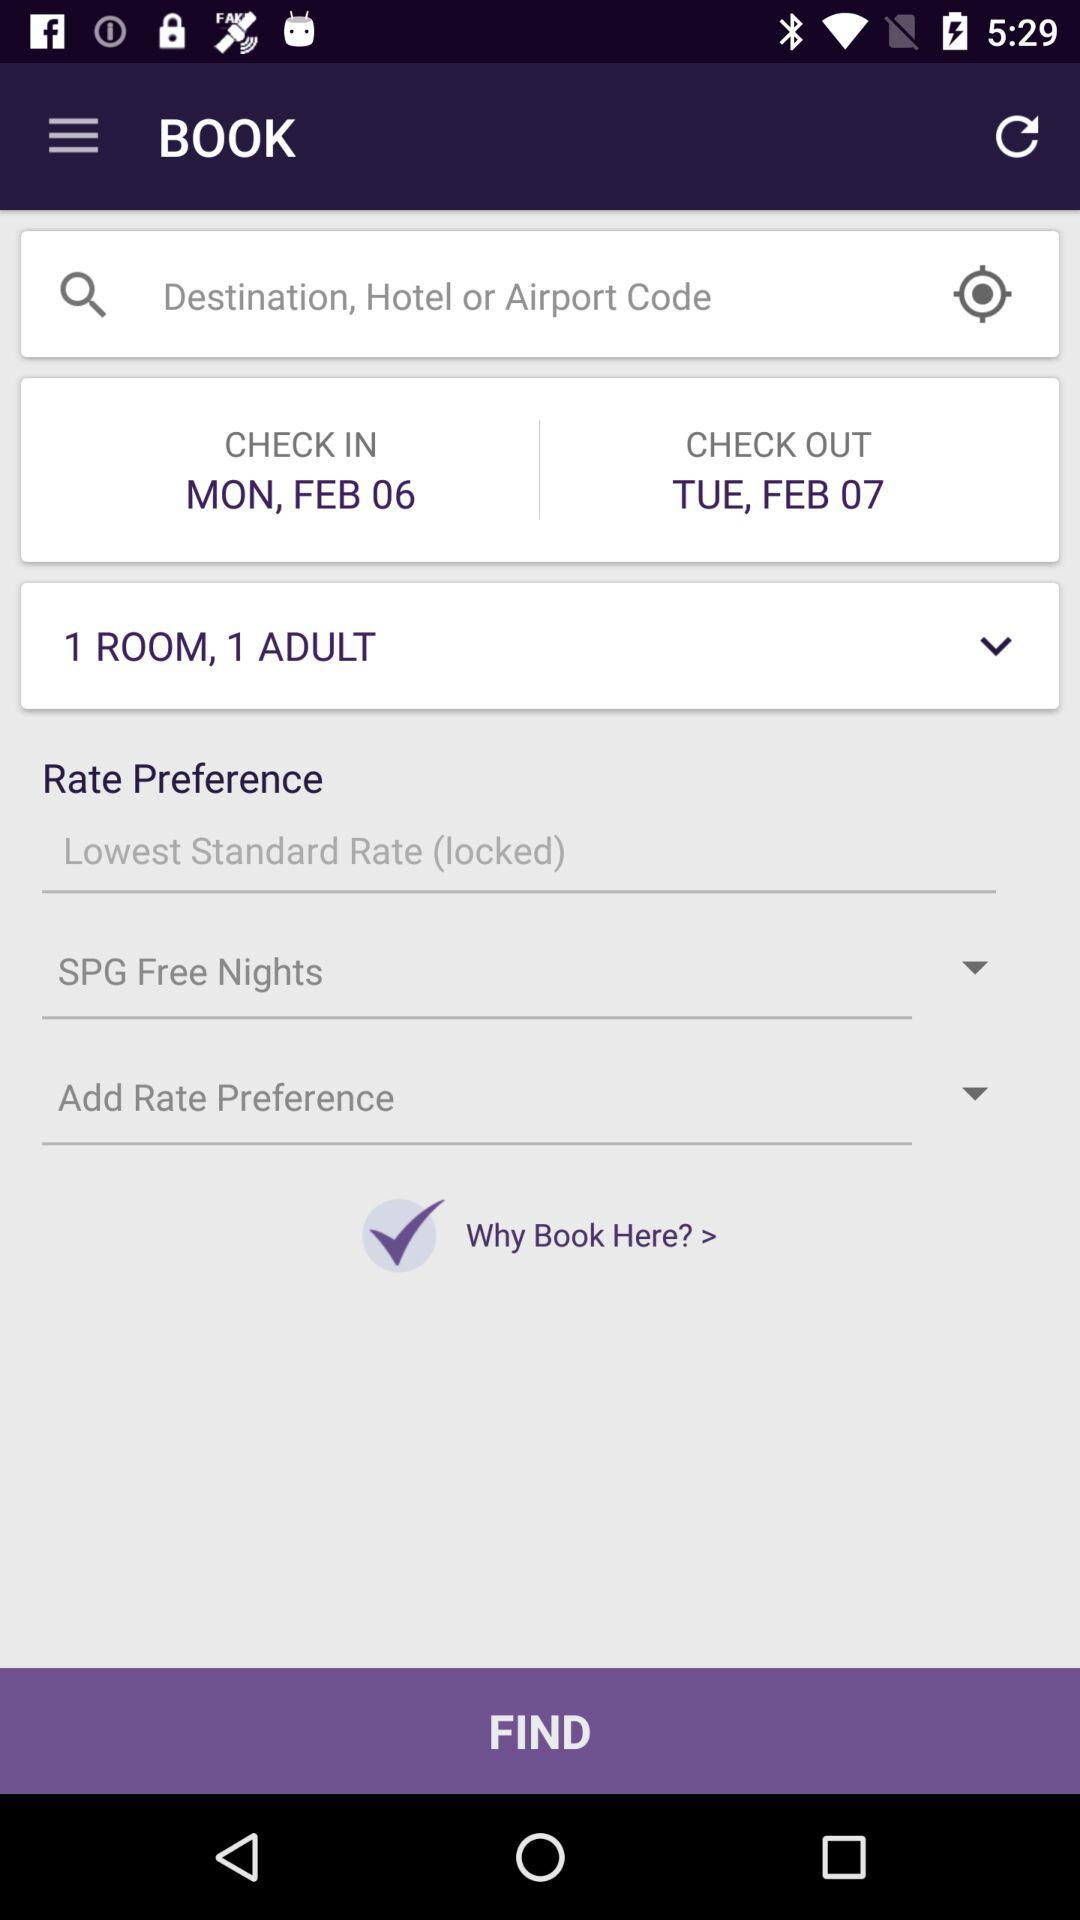How many adults in 1 room? There is only 1 adult in one room. 